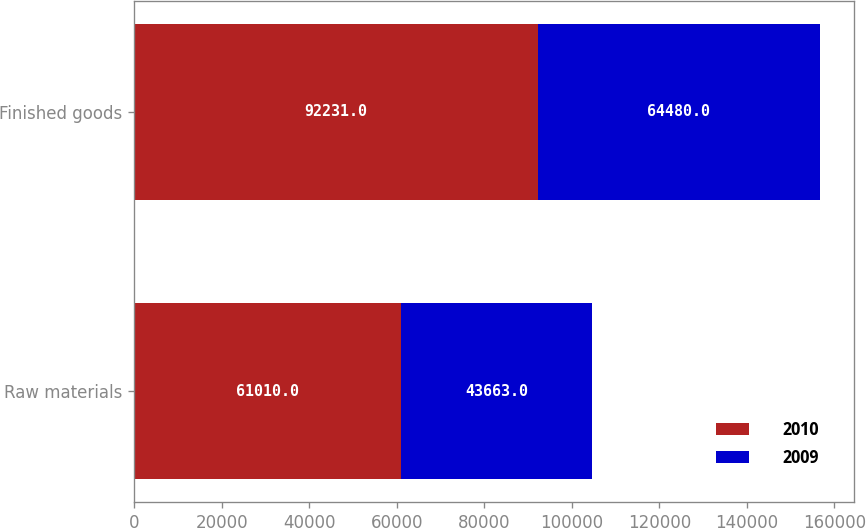<chart> <loc_0><loc_0><loc_500><loc_500><stacked_bar_chart><ecel><fcel>Raw materials<fcel>Finished goods<nl><fcel>2010<fcel>61010<fcel>92231<nl><fcel>2009<fcel>43663<fcel>64480<nl></chart> 